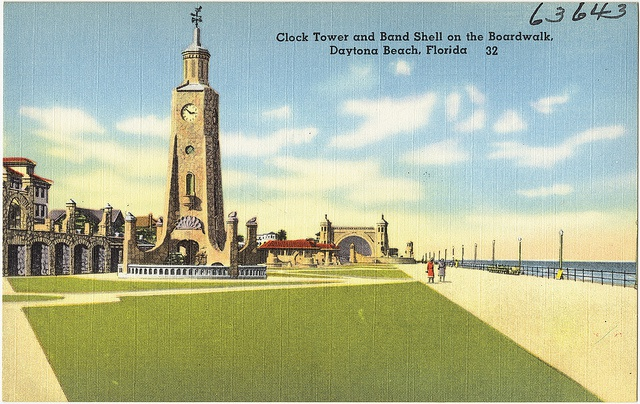Describe the objects in this image and their specific colors. I can see clock in white, khaki, tan, gray, and lightyellow tones, people in white, gray, darkgray, tan, and khaki tones, people in white, red, olive, gray, and khaki tones, clock in white, black, and gray tones, and people in white, tan, gray, khaki, and olive tones in this image. 